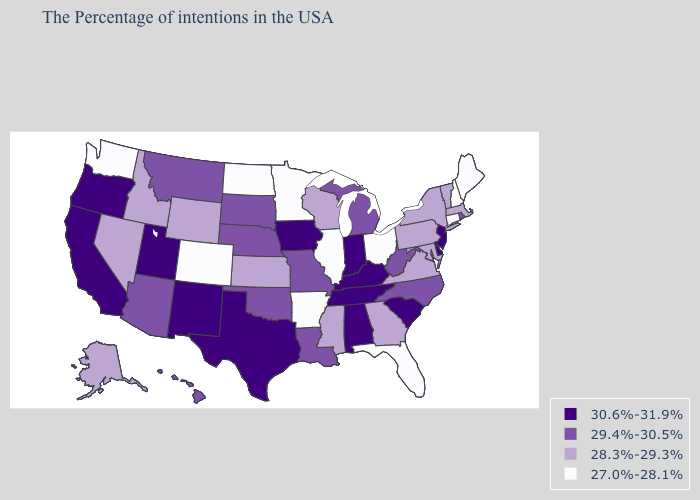What is the highest value in the USA?
Give a very brief answer. 30.6%-31.9%. What is the highest value in states that border South Dakota?
Short answer required. 30.6%-31.9%. What is the lowest value in the South?
Keep it brief. 27.0%-28.1%. Name the states that have a value in the range 27.0%-28.1%?
Concise answer only. Maine, New Hampshire, Connecticut, Ohio, Florida, Illinois, Arkansas, Minnesota, North Dakota, Colorado, Washington. What is the highest value in the MidWest ?
Be succinct. 30.6%-31.9%. Does Georgia have a lower value than New Jersey?
Answer briefly. Yes. Does Mississippi have a higher value than Colorado?
Answer briefly. Yes. Name the states that have a value in the range 29.4%-30.5%?
Give a very brief answer. Rhode Island, North Carolina, West Virginia, Michigan, Louisiana, Missouri, Nebraska, Oklahoma, South Dakota, Montana, Arizona, Hawaii. Among the states that border New Jersey , which have the highest value?
Give a very brief answer. Delaware. What is the value of Montana?
Answer briefly. 29.4%-30.5%. Among the states that border Oregon , does California have the highest value?
Write a very short answer. Yes. Does Idaho have the same value as Hawaii?
Answer briefly. No. Does Kansas have a higher value than North Dakota?
Write a very short answer. Yes. Name the states that have a value in the range 29.4%-30.5%?
Concise answer only. Rhode Island, North Carolina, West Virginia, Michigan, Louisiana, Missouri, Nebraska, Oklahoma, South Dakota, Montana, Arizona, Hawaii. Which states have the lowest value in the Northeast?
Write a very short answer. Maine, New Hampshire, Connecticut. 